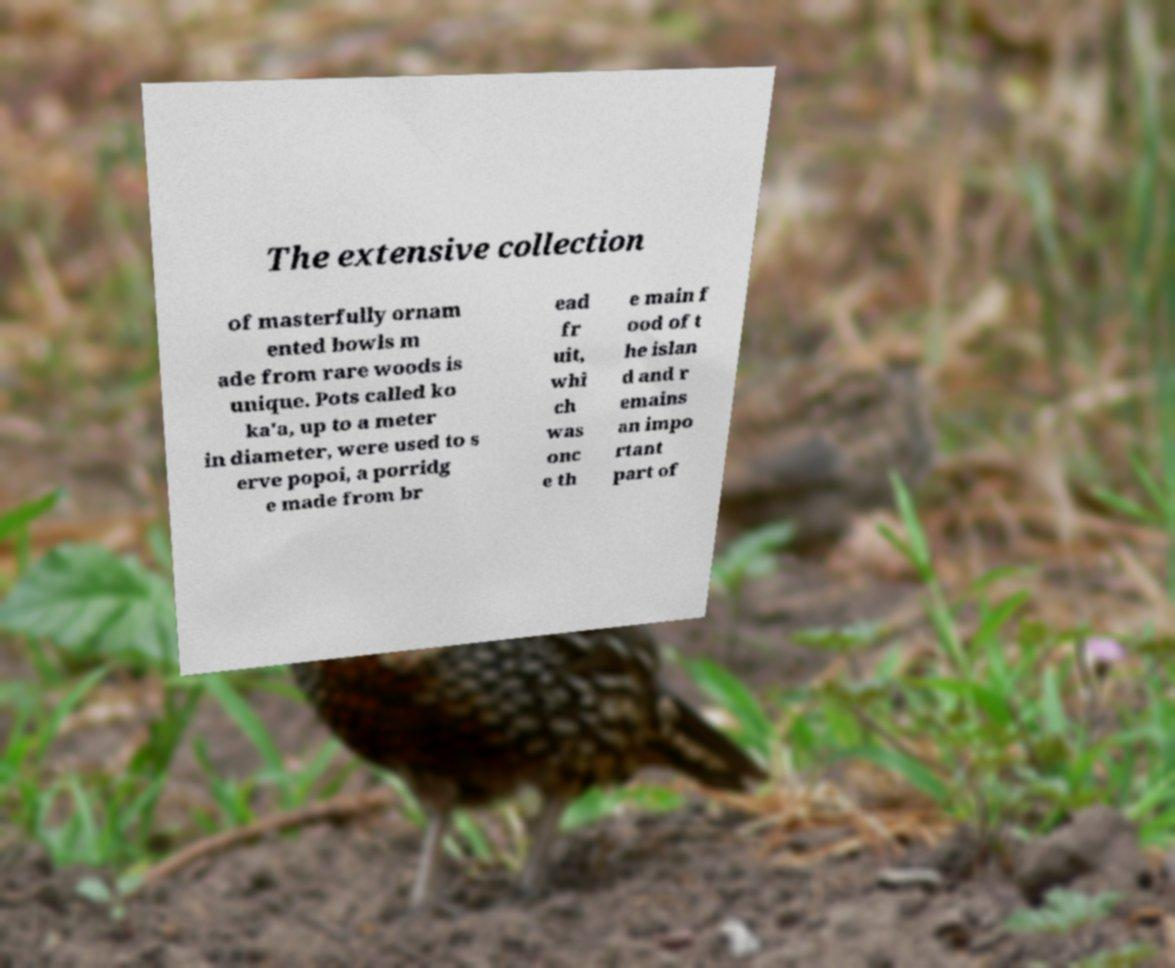Could you extract and type out the text from this image? The extensive collection of masterfully ornam ented bowls m ade from rare woods is unique. Pots called ko ka'a, up to a meter in diameter, were used to s erve popoi, a porridg e made from br ead fr uit, whi ch was onc e th e main f ood of t he islan d and r emains an impo rtant part of 